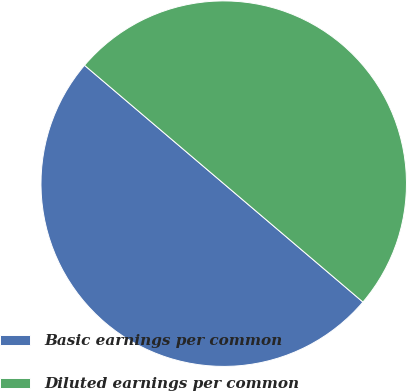<chart> <loc_0><loc_0><loc_500><loc_500><pie_chart><fcel>Basic earnings per common<fcel>Diluted earnings per common<nl><fcel>50.0%<fcel>50.0%<nl></chart> 